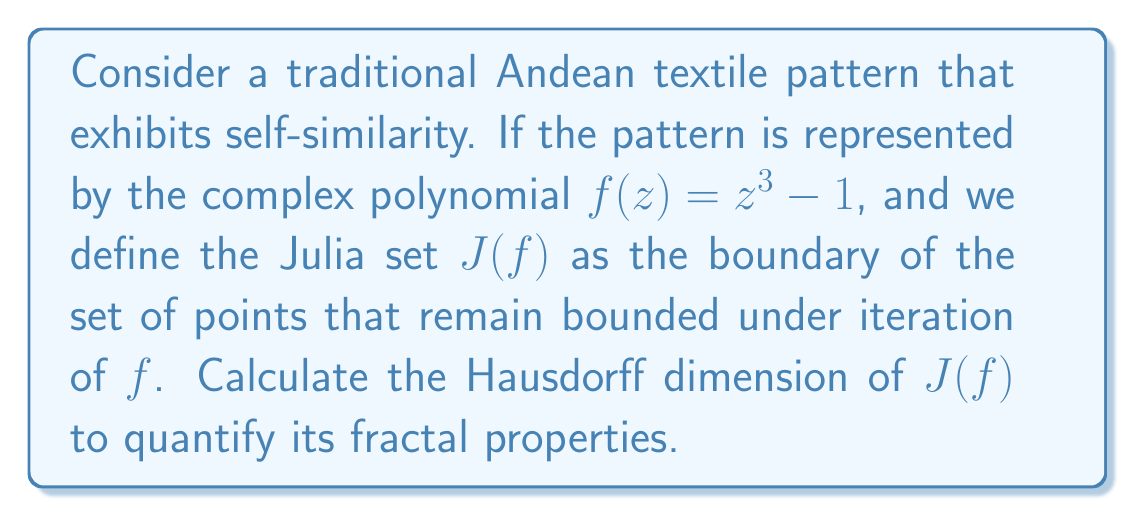Show me your answer to this math problem. To solve this problem, we'll follow these steps:

1) The Julia set of $f(z) = z^3 - 1$ is known as the "Douady rabbit" fractal.

2) For polynomials of the form $z^d + c$, where $d \geq 2$, the Hausdorff dimension of the Julia set is given by the formula:

   $$\text{dim}_H(J(f)) = 2 - \frac{\log 2}{\log d}$$

3) In our case, $d = 3$ (the degree of the polynomial).

4) Substituting this into the formula:

   $$\text{dim}_H(J(f)) = 2 - \frac{\log 2}{\log 3}$$

5) Calculate:
   
   $$2 - \frac{\log 2}{\log 3} \approx 2 - 0.6309 \approx 1.3691$$

This result quantifies the fractal properties of the pattern, showing it has a non-integer dimension between 1 and 2, characteristic of fractals.
Answer: $2 - \frac{\log 2}{\log 3} \approx 1.3691$ 